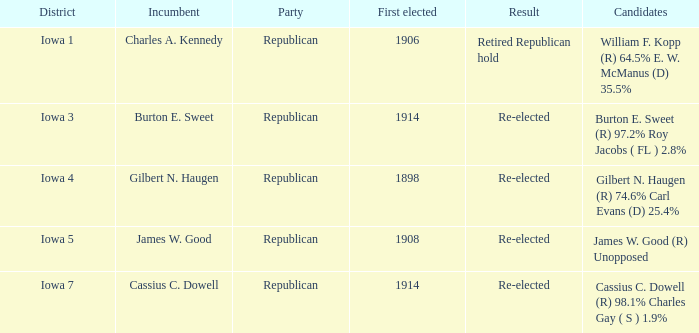Parse the full table. {'header': ['District', 'Incumbent', 'Party', 'First elected', 'Result', 'Candidates'], 'rows': [['Iowa 1', 'Charles A. Kennedy', 'Republican', '1906', 'Retired Republican hold', 'William F. Kopp (R) 64.5% E. W. McManus (D) 35.5%'], ['Iowa 3', 'Burton E. Sweet', 'Republican', '1914', 'Re-elected', 'Burton E. Sweet (R) 97.2% Roy Jacobs ( FL ) 2.8%'], ['Iowa 4', 'Gilbert N. Haugen', 'Republican', '1898', 'Re-elected', 'Gilbert N. Haugen (R) 74.6% Carl Evans (D) 25.4%'], ['Iowa 5', 'James W. Good', 'Republican', '1908', 'Re-elected', 'James W. Good (R) Unopposed'], ['Iowa 7', 'Cassius C. Dowell', 'Republican', '1914', 'Re-elected', 'Cassius C. Dowell (R) 98.1% Charles Gay ( S ) 1.9%']]} What political party for burton e. sweet? Republican. 